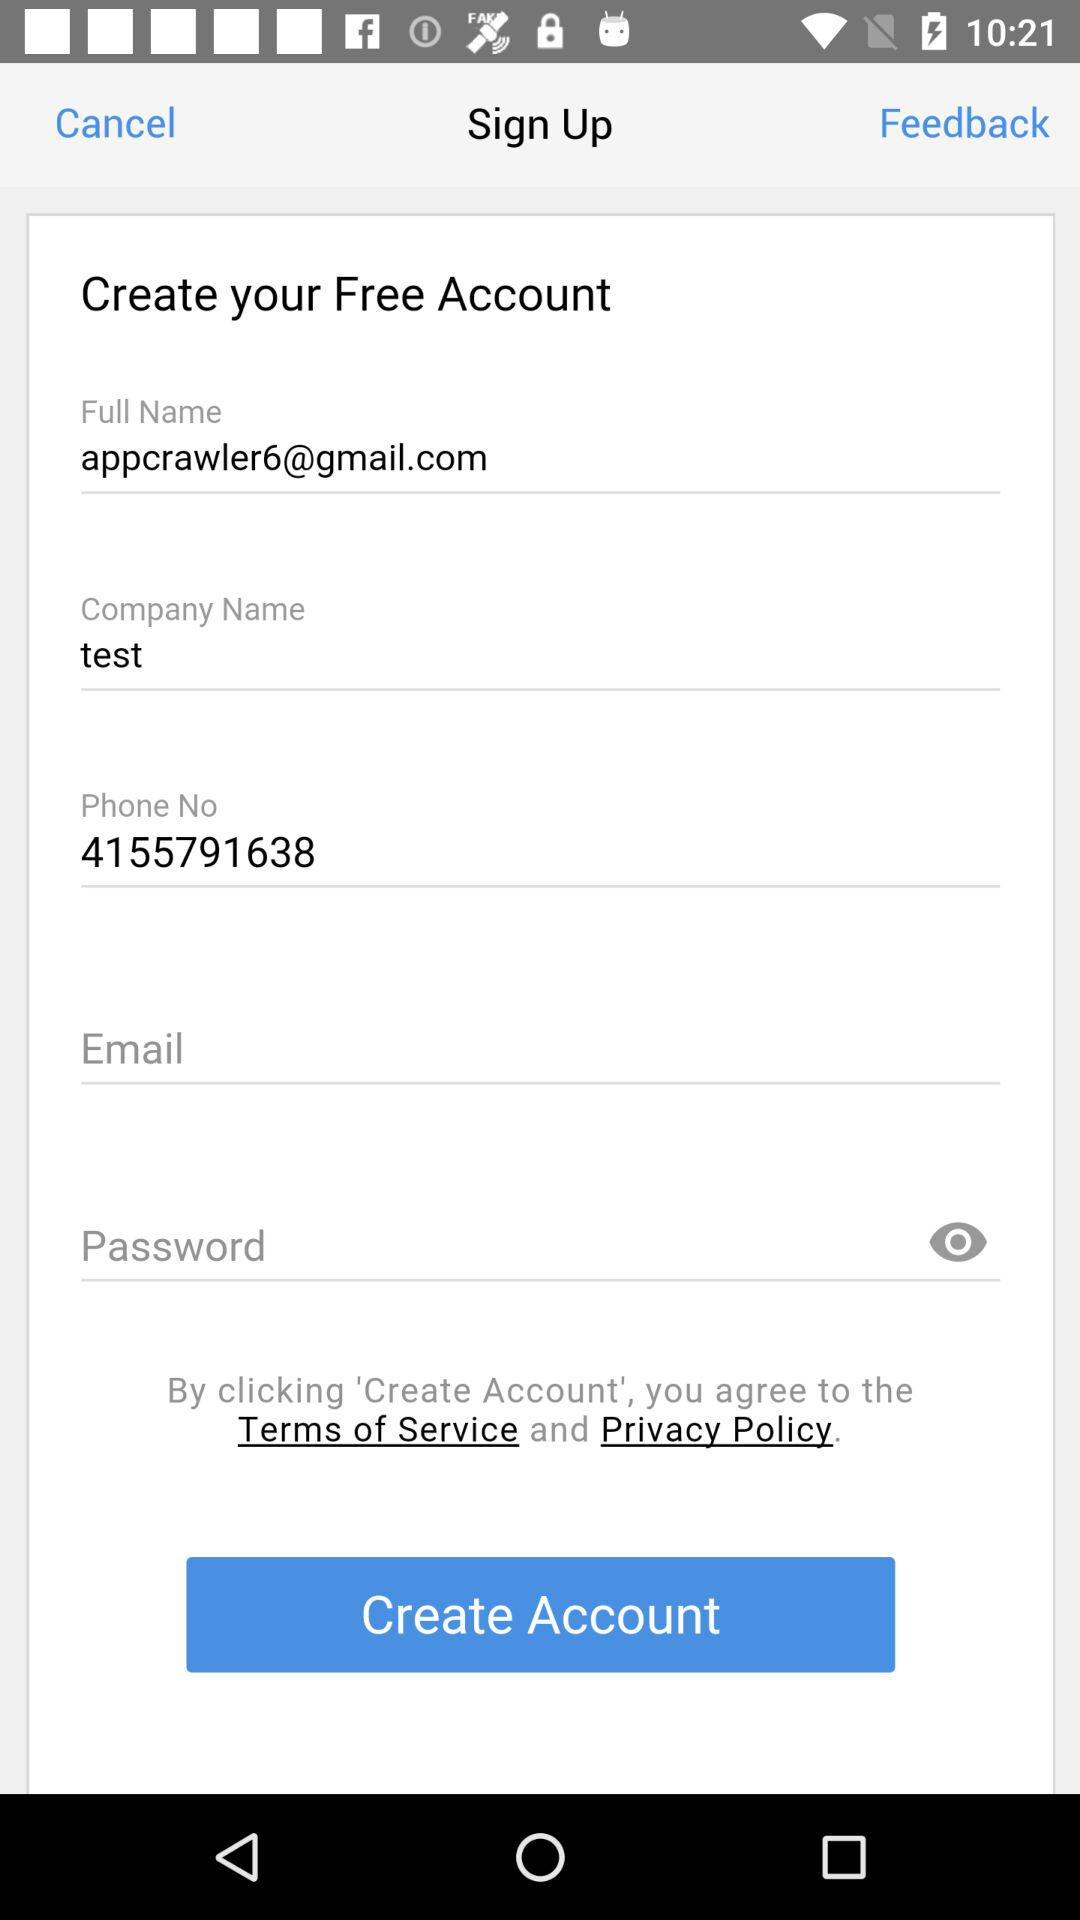What is the email address? The email address is appcrawler6@gmail.com. 